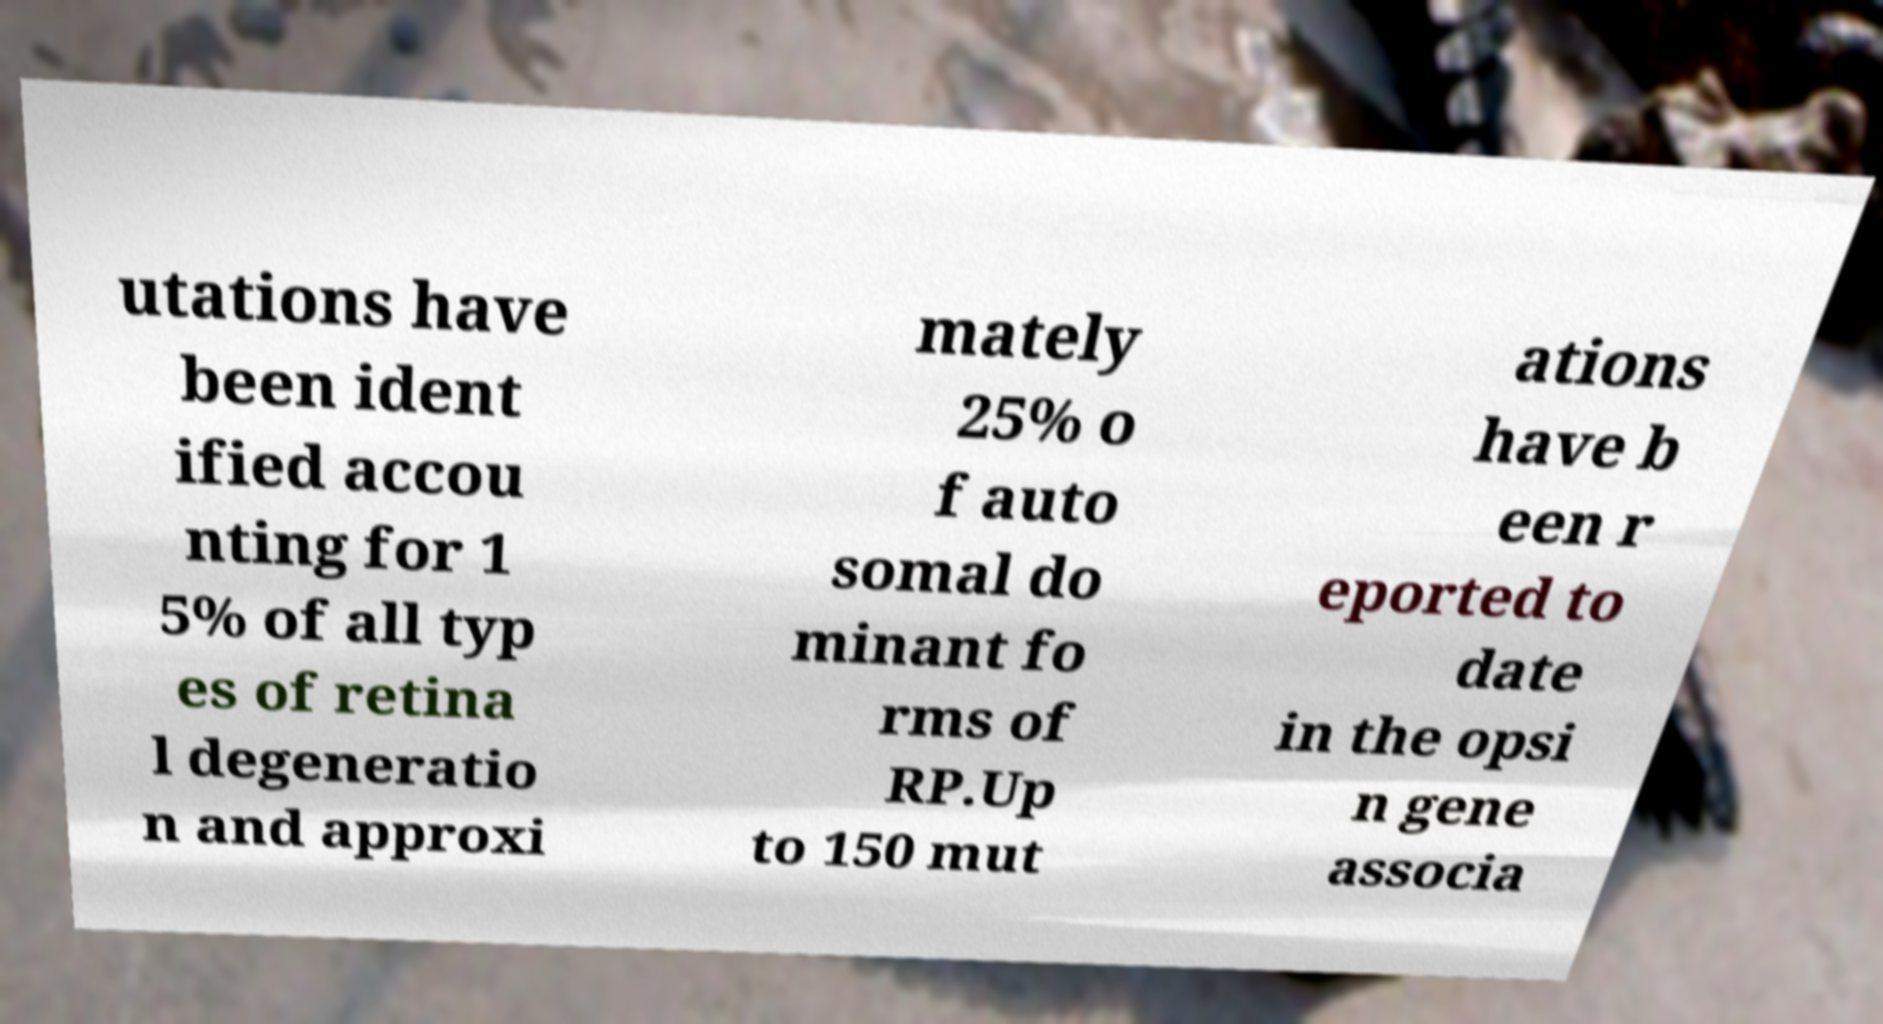Could you extract and type out the text from this image? utations have been ident ified accou nting for 1 5% of all typ es of retina l degeneratio n and approxi mately 25% o f auto somal do minant fo rms of RP.Up to 150 mut ations have b een r eported to date in the opsi n gene associa 